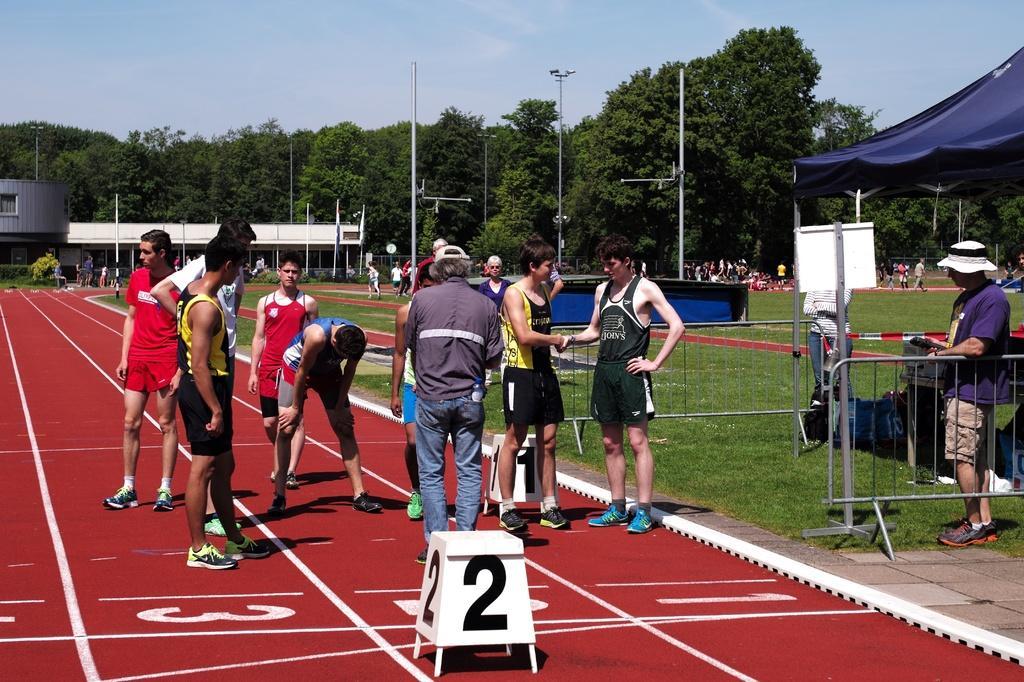How would you summarize this image in a sentence or two? In this picture there are group of people standing the in foreground. On the right side of the image there is a person standing behind the railing and there is a tent and there is a board on the pole. At the back there are group of people and there are trees, poles and there is a building. At the top there is a sky. At the bottom there is grass. 